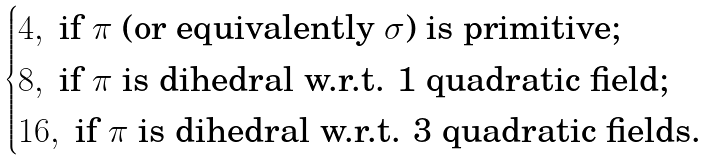<formula> <loc_0><loc_0><loc_500><loc_500>\begin{cases} 4 , \text { if $\pi$ (or equivalently $\sigma$) is primitive;} \\ 8 , \text { if $\pi$ is dihedral w.r.t. 1 quadratic field;} \\ 1 6 , \text { if $\pi$ is dihedral w.r.t. 3 quadratic fields.} \end{cases}</formula> 